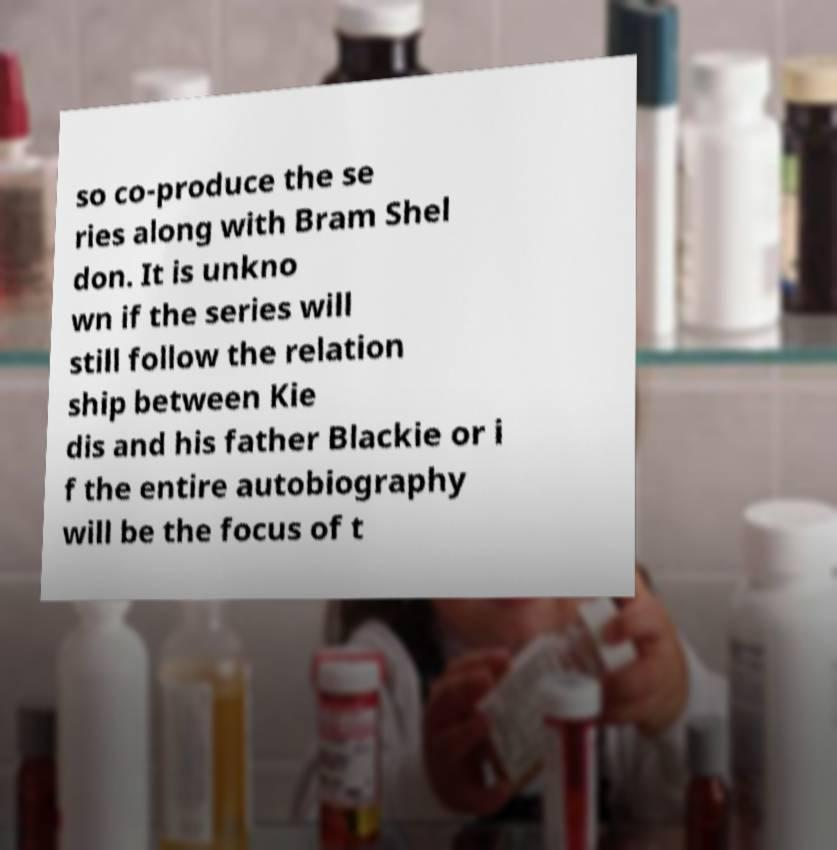There's text embedded in this image that I need extracted. Can you transcribe it verbatim? so co-produce the se ries along with Bram Shel don. It is unkno wn if the series will still follow the relation ship between Kie dis and his father Blackie or i f the entire autobiography will be the focus of t 